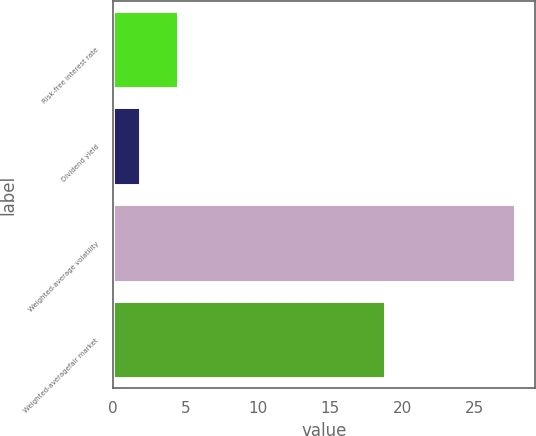Convert chart. <chart><loc_0><loc_0><loc_500><loc_500><bar_chart><fcel>Risk-free interest rate<fcel>Dividend yield<fcel>Weighted-average volatility<fcel>Weighted-averagefair market<nl><fcel>4.48<fcel>1.86<fcel>27.84<fcel>18.85<nl></chart> 